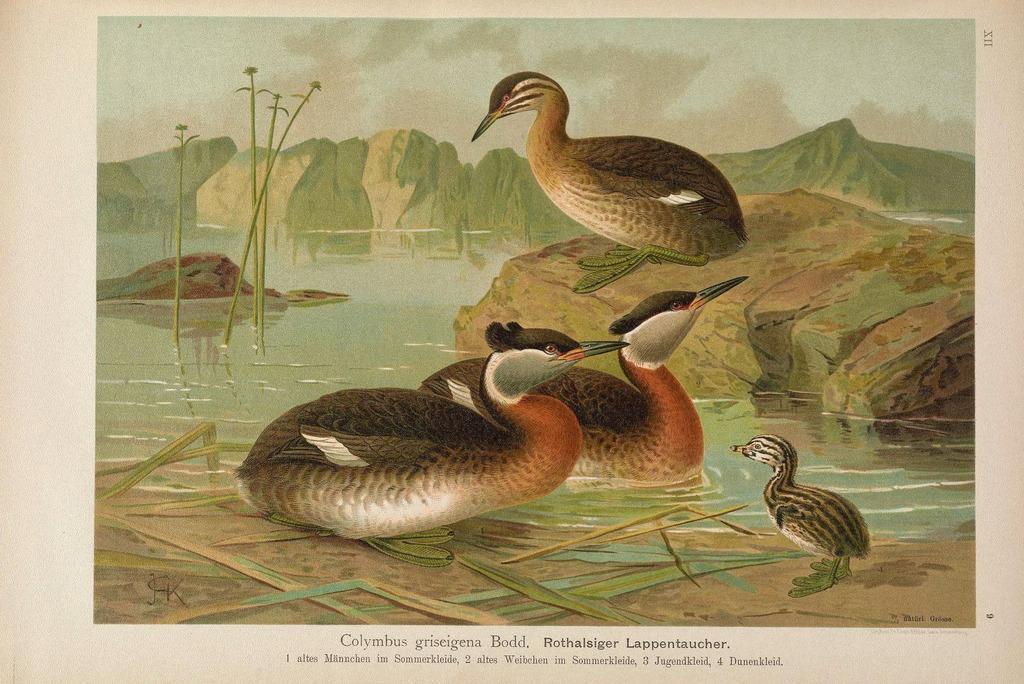In one or two sentences, can you explain what this image depicts? In this image we can see the picture of some birds, a water body, the rock, plants, the hills and the sky. On the bottom of the image we can see some text. 